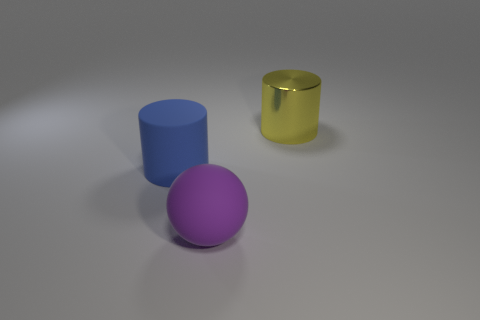Add 2 big purple balls. How many objects exist? 5 Subtract 1 balls. How many balls are left? 0 Subtract all balls. How many objects are left? 2 Subtract all gray cylinders. How many blue balls are left? 0 Add 3 metal things. How many metal things exist? 4 Subtract 0 cyan spheres. How many objects are left? 3 Subtract all yellow spheres. Subtract all green cubes. How many spheres are left? 1 Subtract all rubber cylinders. Subtract all metal cylinders. How many objects are left? 1 Add 1 large rubber balls. How many large rubber balls are left? 2 